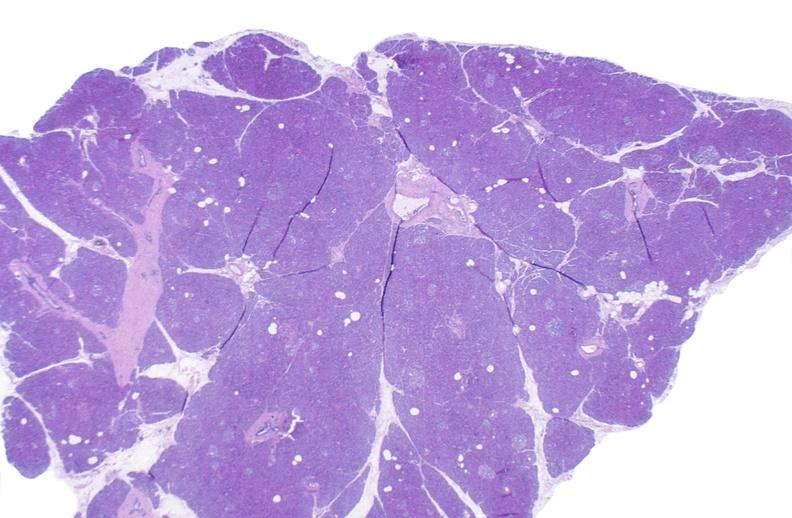does choanal atresia show normal pancreas?
Answer the question using a single word or phrase. No 